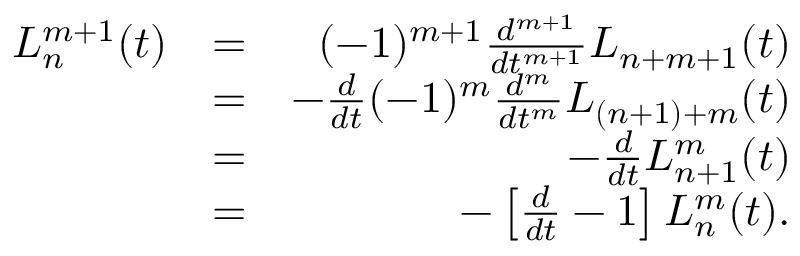<formula> <loc_0><loc_0><loc_500><loc_500>\begin{array} { r l r } { L _ { n } ^ { m + 1 } ( t ) } & { = } & { ( - 1 ) ^ { m + 1 } \frac { d ^ { m + 1 } } { d t ^ { m + 1 } } L _ { n + m + 1 } ( t ) } \\ & { = } & { - \frac { d } { d t } ( - 1 ) ^ { m } \frac { d ^ { m } } { d t ^ { m } } L _ { ( n + 1 ) + m } ( t ) } \\ & { = } & { - \frac { d } { d t } L _ { n + 1 } ^ { m } ( t ) } \\ & { = } & { - \left [ \frac { d } { d t } - 1 \right ] L _ { n } ^ { m } ( t ) . } \end{array}</formula> 